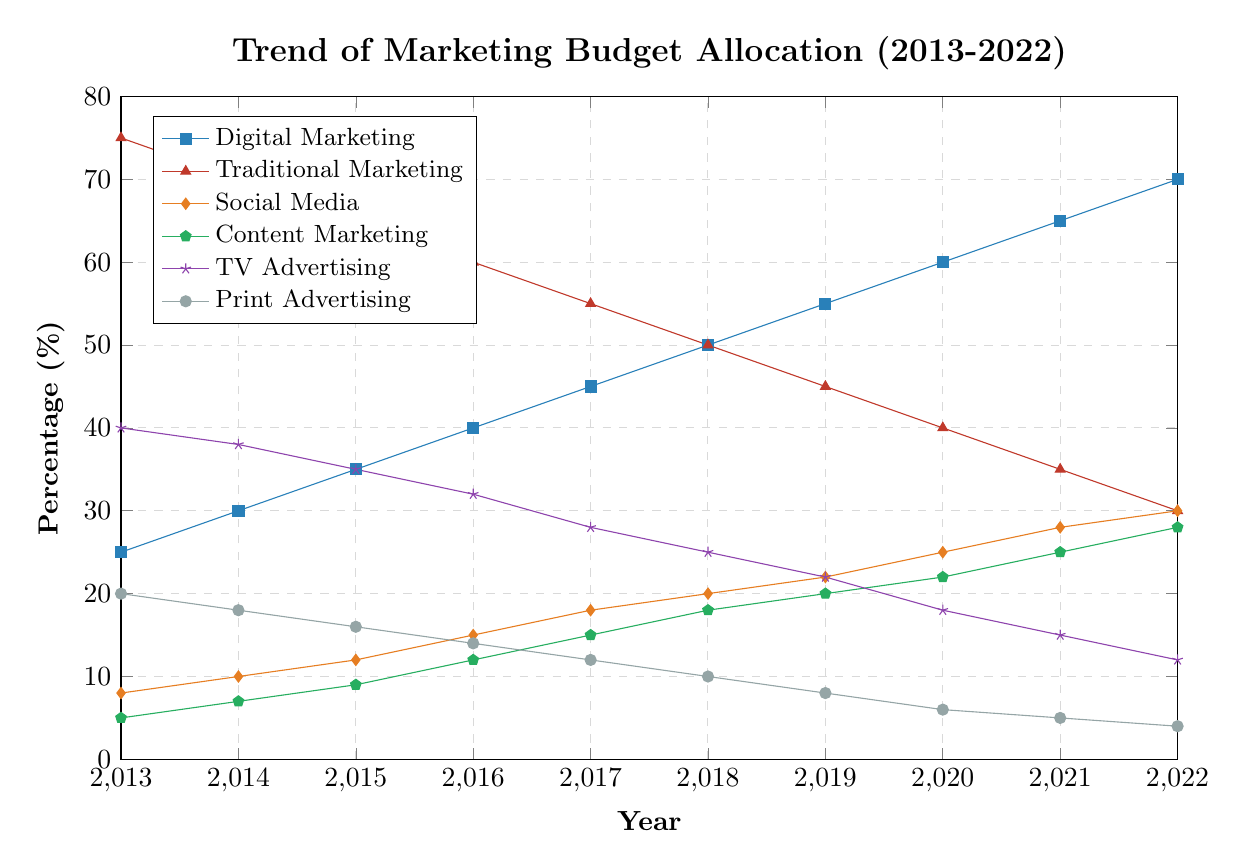What is the overall trend in the allocation of the marketing budget between digital and traditional marketing from 2013 to 2022? The figure shows a decreasing trend for traditional marketing from 75% in 2013 to 30% in 2022. Meanwhile, digital marketing shows an increasing trend from 25% in 2013 to 70% in 2022. This indicates a shift in budget allocation from traditional to digital marketing over the past decade.
Answer: Shift from traditional to digital marketing In which year did digital marketing and traditional marketing have an equal budget allocation? By observing the lines representing digital and traditional marketing, they intersect at the year 2018, where both have a budget allocation of 50%.
Answer: 2018 Which category has the highest percentage in 2022, and what is that percentage? In 2022, the category with the highest percentage is digital marketing with a 70% budget allocation.
Answer: Digital marketing, 70% How much did the budget allocation for print advertising decrease from 2013 to 2022? The value for print advertising in 2013 is 20% and in 2022 is 4%. The decrease is calculated as 20% - 4% = 16%.
Answer: 16% What is the overall trend for social media marketing from 2013 to 2022? The figure shows an increasing trend for social media marketing which increases from 8% in 2013 to 30% in 2022.
Answer: Increasing trend How does the budget allocation for content marketing in 2022 compare to that in 2013? Content marketing allocation increased from 5% in 2013 to 28% in 2022. Thus, there's an increase of 23%.
Answer: Increased by 23% In which year did TV advertising fall below 20% of the budget allocation? Observing the TV advertising line, it falls below 20% starting in 2020, where it is allocated 18%.
Answer: 2020 What is the sum of the budget allocations for social media and content marketing in 2021? In 2021, social media is allocated 28% and content marketing is allocated 25%. The sum is 28% + 25% = 53%.
Answer: 53% By how many percentage points has the budget allocation for TV advertising changed from 2015 to 2019? In 2015, TV advertising was at 35% and in 2019 it decreased to 22%. The change is 35% - 22% = 13%.
Answer: 13% What was the average percentage allocation for digital marketing over the decade from 2013 to 2022? The percentages for digital marketing from 2013 to 2022 are: 25, 30, 35, 40, 45, 50, 55, 60, 65, 70. Sum these values to get 475. There are 10 years, so the average is 475 / 10 = 47.5%.
Answer: 47.5% 